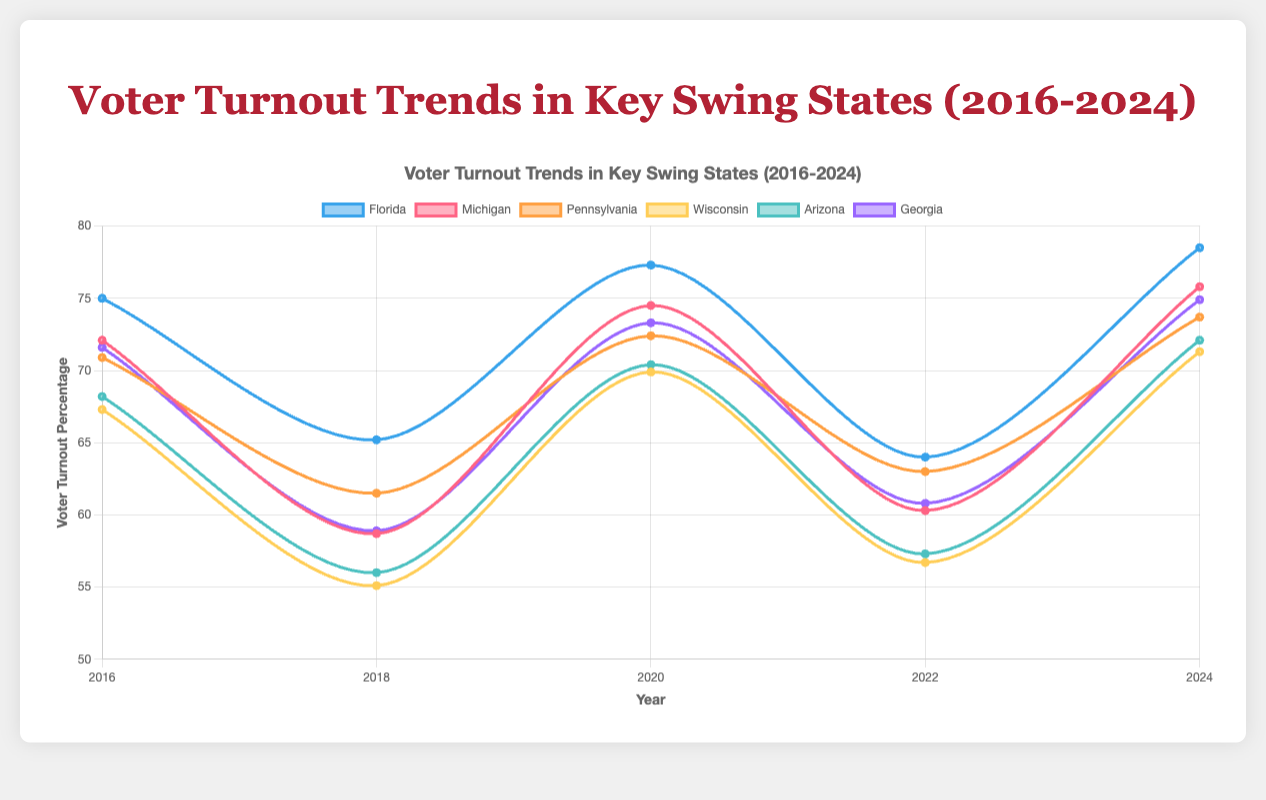What is the trend in voter turnout percentage for Florida from 2016 to 2024? The plot shows voter turnout percentages for Florida as follows: 2016 (75.0%), 2018 (65.2%), 2020 (77.3%), 2022 (64.0%), and 2024 (78.5%). There is a general upward trend overall despite some fluctuations.
Answer: Generally upward Among the years provided, which year had the highest voter turnout in Michigan? Looking at the line for Michigan on the chart, the highest voter turnout percentage is in 2024 with 75.8%.
Answer: 2024 What is the percentage difference in voter turnout between 2016 and 2024 in Pennsylvania? The voter turnout for Pennsylvania in 2016 is 70.9%, and in 2024 it is 73.7%. The difference is calculated as 73.7 - 70.9 = 2.8%.
Answer: 2.8% Which state had the lowest voter turnout percentage in 2022? By examining the graph, Wisconsin had the lowest voter turnout percentage in 2022 with 56.7%.
Answer: Wisconsin In which year did Arizona have the lowest voter turnout, and what was the percentage? Arizona had its lowest voter turnout in 2018 with a percentage of 56.0%, as shown in the line chart.
Answer: 2018, 56.0% How does the voter turnout in Wisconsin in 2024 compare to its turnout in 2018? The voter turnout in Wisconsin for 2024 is 71.3%, while in 2018 it was 55.1%. Comparing these, 71.3% is significantly higher than 55.1%.
Answer: 2024 is higher What is the average voter turnout percentage in Georgia over the given years? The voter turnouts for Georgia are: 2016 (71.6%), 2018 (58.9%), 2020 (73.3%), 2022 (60.8%), and 2024 (74.9%). The sum is 71.6 + 58.9 + 73.3 + 60.8 + 74.9 = 339.5. The average is 339.5 / 5 = 67.9%.
Answer: 67.9% Which two states had the most similar voter turnout percentages in 2020, and what were the percentages? In 2020, Florida had 77.3% and Michigan had 74.5%. Among the states, Michigan and Pennsylvania had the most similar percentages of 74.5% and 72.4%, respectively, with a difference of 2.1%.
Answer: Michigan and Pennsylvania, 74.5% and 72.4% What is the trend in voter turnout for Wisconsin from 2016 to 2024? By observing the line chart for Wisconsin, the turnout trends are: 2016 (67.3%), 2018 (55.1%), 2020 (69.9%), 2022 (56.7%), and 2024 (71.3%). Despite the fluctuations, the overall trend shows an increase from 2016 to 2024.
Answer: Generally increasing 